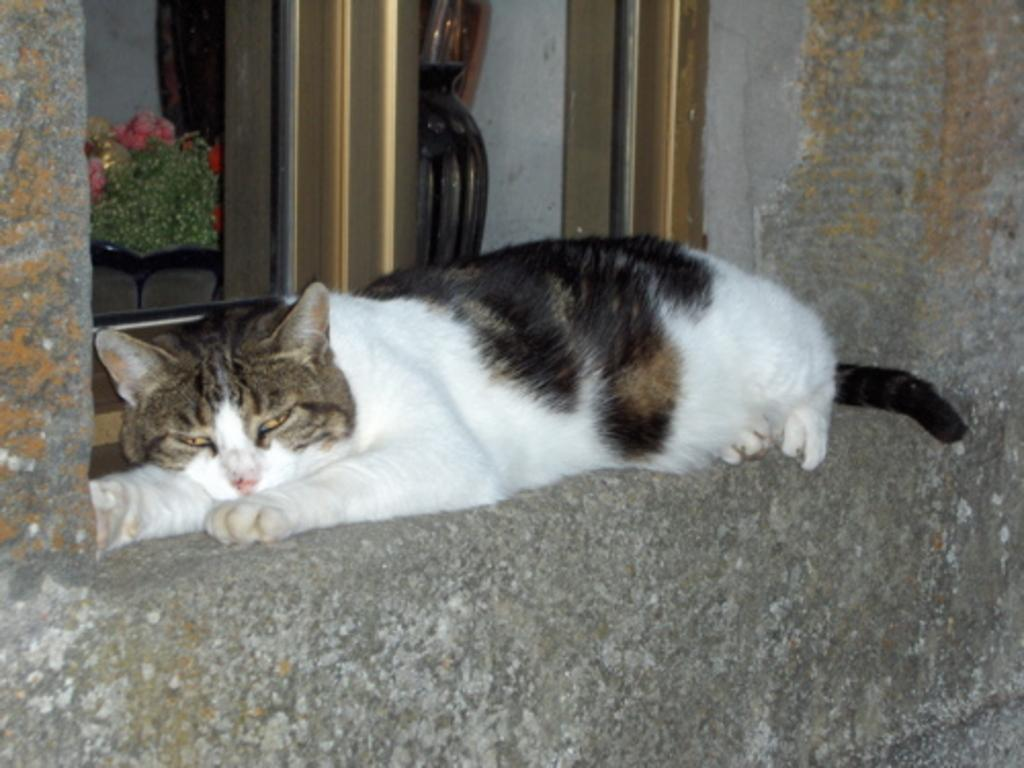What type of animal is present in the image? There is a cat in the image. Where is the cat located in the image? The cat is lying on a platform. What can be seen through the window in the image? The facts do not specify what can be seen through the window. What is the background of the image made of? There is a wall in the image, which suggests the background is made of a solid material. What is placed on the platform with the cat? The facts mention a vase in the image, but it does not specify if it is on the platform with the cat. Can you describe any other objects in the image? The facts mention that there are objects in the image, but they do not specify what they are. What type of trees can be seen through the window in the image? The facts do not specify what can be seen through the window, so we cannot determine if there are any trees visible. 